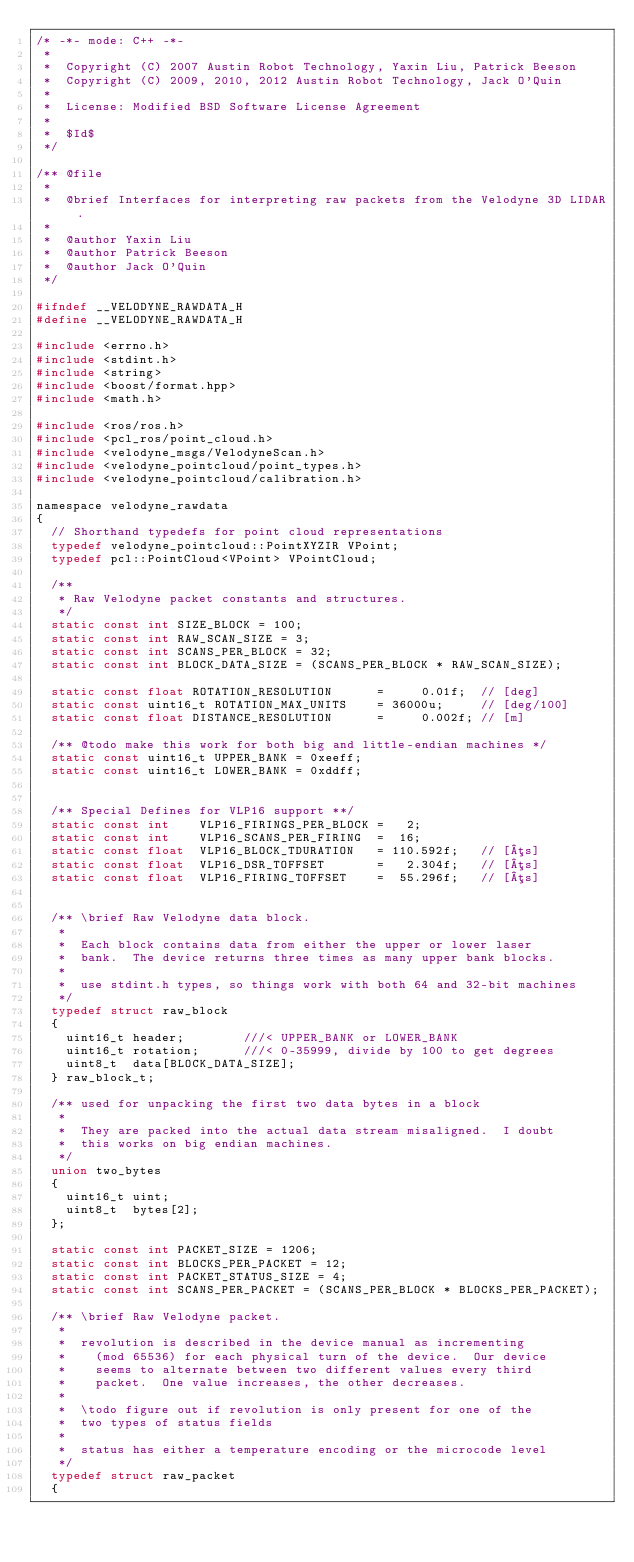<code> <loc_0><loc_0><loc_500><loc_500><_C_>/* -*- mode: C++ -*-
 *
 *  Copyright (C) 2007 Austin Robot Technology, Yaxin Liu, Patrick Beeson
 *  Copyright (C) 2009, 2010, 2012 Austin Robot Technology, Jack O'Quin
 *
 *  License: Modified BSD Software License Agreement
 *
 *  $Id$
 */

/** @file
 *
 *  @brief Interfaces for interpreting raw packets from the Velodyne 3D LIDAR.
 *
 *  @author Yaxin Liu
 *  @author Patrick Beeson
 *  @author Jack O'Quin
 */

#ifndef __VELODYNE_RAWDATA_H
#define __VELODYNE_RAWDATA_H

#include <errno.h>
#include <stdint.h>
#include <string>
#include <boost/format.hpp>
#include <math.h>

#include <ros/ros.h>
#include <pcl_ros/point_cloud.h>
#include <velodyne_msgs/VelodyneScan.h>
#include <velodyne_pointcloud/point_types.h>
#include <velodyne_pointcloud/calibration.h>

namespace velodyne_rawdata
{
  // Shorthand typedefs for point cloud representations
  typedef velodyne_pointcloud::PointXYZIR VPoint;
  typedef pcl::PointCloud<VPoint> VPointCloud;

  /**
   * Raw Velodyne packet constants and structures.
   */
  static const int SIZE_BLOCK = 100;
  static const int RAW_SCAN_SIZE = 3;
  static const int SCANS_PER_BLOCK = 32;
  static const int BLOCK_DATA_SIZE = (SCANS_PER_BLOCK * RAW_SCAN_SIZE);

  static const float ROTATION_RESOLUTION      =     0.01f;  // [deg]
  static const uint16_t ROTATION_MAX_UNITS    = 36000u;     // [deg/100]
  static const float DISTANCE_RESOLUTION      =     0.002f; // [m]

  /** @todo make this work for both big and little-endian machines */
  static const uint16_t UPPER_BANK = 0xeeff;
  static const uint16_t LOWER_BANK = 0xddff;
  
  
  /** Special Defines for VLP16 support **/
  static const int    VLP16_FIRINGS_PER_BLOCK =   2;
  static const int    VLP16_SCANS_PER_FIRING  =  16;
  static const float  VLP16_BLOCK_TDURATION   = 110.592f;   // [µs]
  static const float  VLP16_DSR_TOFFSET       =   2.304f;   // [µs]
  static const float  VLP16_FIRING_TOFFSET    =  55.296f;   // [µs]
  

  /** \brief Raw Velodyne data block.
   *
   *  Each block contains data from either the upper or lower laser
   *  bank.  The device returns three times as many upper bank blocks.
   *
   *  use stdint.h types, so things work with both 64 and 32-bit machines
   */
  typedef struct raw_block
  {
    uint16_t header;        ///< UPPER_BANK or LOWER_BANK
    uint16_t rotation;      ///< 0-35999, divide by 100 to get degrees
    uint8_t  data[BLOCK_DATA_SIZE];
  } raw_block_t;

  /** used for unpacking the first two data bytes in a block
   *
   *  They are packed into the actual data stream misaligned.  I doubt
   *  this works on big endian machines.
   */
  union two_bytes
  {
    uint16_t uint;
    uint8_t  bytes[2];
  };

  static const int PACKET_SIZE = 1206;
  static const int BLOCKS_PER_PACKET = 12;
  static const int PACKET_STATUS_SIZE = 4;
  static const int SCANS_PER_PACKET = (SCANS_PER_BLOCK * BLOCKS_PER_PACKET);

  /** \brief Raw Velodyne packet.
   *
   *  revolution is described in the device manual as incrementing
   *    (mod 65536) for each physical turn of the device.  Our device
   *    seems to alternate between two different values every third
   *    packet.  One value increases, the other decreases.
   *
   *  \todo figure out if revolution is only present for one of the
   *  two types of status fields
   *
   *  status has either a temperature encoding or the microcode level
   */
  typedef struct raw_packet
  {</code> 